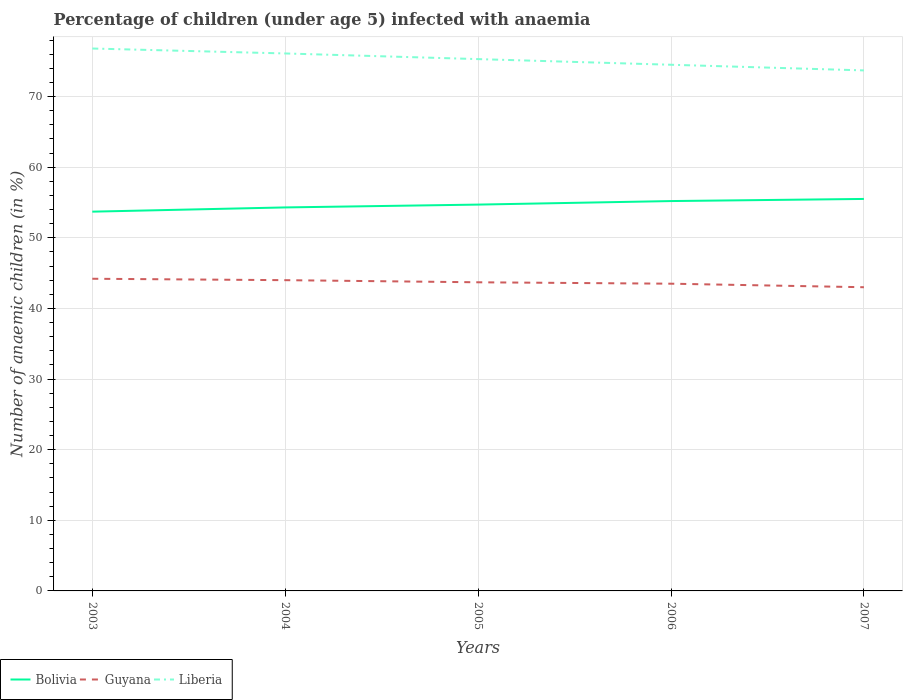Is the number of lines equal to the number of legend labels?
Provide a succinct answer. Yes. Across all years, what is the maximum percentage of children infected with anaemia in in Bolivia?
Your answer should be compact. 53.7. In which year was the percentage of children infected with anaemia in in Guyana maximum?
Offer a terse response. 2007. What is the total percentage of children infected with anaemia in in Guyana in the graph?
Your answer should be compact. 1.2. What is the difference between the highest and the second highest percentage of children infected with anaemia in in Liberia?
Give a very brief answer. 3.1. Is the percentage of children infected with anaemia in in Liberia strictly greater than the percentage of children infected with anaemia in in Guyana over the years?
Your response must be concise. No. How many years are there in the graph?
Make the answer very short. 5. Does the graph contain any zero values?
Your answer should be very brief. No. Does the graph contain grids?
Give a very brief answer. Yes. What is the title of the graph?
Provide a succinct answer. Percentage of children (under age 5) infected with anaemia. Does "France" appear as one of the legend labels in the graph?
Keep it short and to the point. No. What is the label or title of the Y-axis?
Make the answer very short. Number of anaemic children (in %). What is the Number of anaemic children (in %) in Bolivia in 2003?
Give a very brief answer. 53.7. What is the Number of anaemic children (in %) in Guyana in 2003?
Your answer should be compact. 44.2. What is the Number of anaemic children (in %) in Liberia in 2003?
Your response must be concise. 76.8. What is the Number of anaemic children (in %) of Bolivia in 2004?
Keep it short and to the point. 54.3. What is the Number of anaemic children (in %) in Liberia in 2004?
Your answer should be very brief. 76.1. What is the Number of anaemic children (in %) in Bolivia in 2005?
Provide a succinct answer. 54.7. What is the Number of anaemic children (in %) of Guyana in 2005?
Keep it short and to the point. 43.7. What is the Number of anaemic children (in %) in Liberia in 2005?
Make the answer very short. 75.3. What is the Number of anaemic children (in %) in Bolivia in 2006?
Your answer should be very brief. 55.2. What is the Number of anaemic children (in %) in Guyana in 2006?
Your answer should be compact. 43.5. What is the Number of anaemic children (in %) of Liberia in 2006?
Your answer should be compact. 74.5. What is the Number of anaemic children (in %) of Bolivia in 2007?
Provide a succinct answer. 55.5. What is the Number of anaemic children (in %) of Liberia in 2007?
Provide a succinct answer. 73.7. Across all years, what is the maximum Number of anaemic children (in %) in Bolivia?
Offer a terse response. 55.5. Across all years, what is the maximum Number of anaemic children (in %) of Guyana?
Your answer should be compact. 44.2. Across all years, what is the maximum Number of anaemic children (in %) of Liberia?
Offer a very short reply. 76.8. Across all years, what is the minimum Number of anaemic children (in %) of Bolivia?
Offer a terse response. 53.7. Across all years, what is the minimum Number of anaemic children (in %) in Guyana?
Offer a terse response. 43. Across all years, what is the minimum Number of anaemic children (in %) in Liberia?
Your answer should be compact. 73.7. What is the total Number of anaemic children (in %) of Bolivia in the graph?
Your answer should be very brief. 273.4. What is the total Number of anaemic children (in %) of Guyana in the graph?
Ensure brevity in your answer.  218.4. What is the total Number of anaemic children (in %) in Liberia in the graph?
Your response must be concise. 376.4. What is the difference between the Number of anaemic children (in %) of Guyana in 2003 and that in 2004?
Provide a short and direct response. 0.2. What is the difference between the Number of anaemic children (in %) in Bolivia in 2003 and that in 2005?
Offer a very short reply. -1. What is the difference between the Number of anaemic children (in %) of Guyana in 2003 and that in 2005?
Your answer should be very brief. 0.5. What is the difference between the Number of anaemic children (in %) of Liberia in 2003 and that in 2005?
Provide a short and direct response. 1.5. What is the difference between the Number of anaemic children (in %) of Bolivia in 2003 and that in 2006?
Make the answer very short. -1.5. What is the difference between the Number of anaemic children (in %) in Liberia in 2003 and that in 2006?
Provide a succinct answer. 2.3. What is the difference between the Number of anaemic children (in %) in Bolivia in 2003 and that in 2007?
Give a very brief answer. -1.8. What is the difference between the Number of anaemic children (in %) of Liberia in 2003 and that in 2007?
Provide a succinct answer. 3.1. What is the difference between the Number of anaemic children (in %) in Bolivia in 2004 and that in 2006?
Provide a short and direct response. -0.9. What is the difference between the Number of anaemic children (in %) of Guyana in 2004 and that in 2006?
Give a very brief answer. 0.5. What is the difference between the Number of anaemic children (in %) in Liberia in 2004 and that in 2006?
Give a very brief answer. 1.6. What is the difference between the Number of anaemic children (in %) in Liberia in 2004 and that in 2007?
Your answer should be very brief. 2.4. What is the difference between the Number of anaemic children (in %) of Liberia in 2005 and that in 2006?
Provide a short and direct response. 0.8. What is the difference between the Number of anaemic children (in %) in Bolivia in 2005 and that in 2007?
Your response must be concise. -0.8. What is the difference between the Number of anaemic children (in %) of Liberia in 2005 and that in 2007?
Ensure brevity in your answer.  1.6. What is the difference between the Number of anaemic children (in %) in Bolivia in 2003 and the Number of anaemic children (in %) in Guyana in 2004?
Provide a succinct answer. 9.7. What is the difference between the Number of anaemic children (in %) in Bolivia in 2003 and the Number of anaemic children (in %) in Liberia in 2004?
Make the answer very short. -22.4. What is the difference between the Number of anaemic children (in %) of Guyana in 2003 and the Number of anaemic children (in %) of Liberia in 2004?
Keep it short and to the point. -31.9. What is the difference between the Number of anaemic children (in %) of Bolivia in 2003 and the Number of anaemic children (in %) of Liberia in 2005?
Your answer should be compact. -21.6. What is the difference between the Number of anaemic children (in %) in Guyana in 2003 and the Number of anaemic children (in %) in Liberia in 2005?
Provide a short and direct response. -31.1. What is the difference between the Number of anaemic children (in %) of Bolivia in 2003 and the Number of anaemic children (in %) of Guyana in 2006?
Give a very brief answer. 10.2. What is the difference between the Number of anaemic children (in %) in Bolivia in 2003 and the Number of anaemic children (in %) in Liberia in 2006?
Keep it short and to the point. -20.8. What is the difference between the Number of anaemic children (in %) of Guyana in 2003 and the Number of anaemic children (in %) of Liberia in 2006?
Ensure brevity in your answer.  -30.3. What is the difference between the Number of anaemic children (in %) in Bolivia in 2003 and the Number of anaemic children (in %) in Guyana in 2007?
Provide a short and direct response. 10.7. What is the difference between the Number of anaemic children (in %) in Bolivia in 2003 and the Number of anaemic children (in %) in Liberia in 2007?
Give a very brief answer. -20. What is the difference between the Number of anaemic children (in %) of Guyana in 2003 and the Number of anaemic children (in %) of Liberia in 2007?
Ensure brevity in your answer.  -29.5. What is the difference between the Number of anaemic children (in %) of Guyana in 2004 and the Number of anaemic children (in %) of Liberia in 2005?
Ensure brevity in your answer.  -31.3. What is the difference between the Number of anaemic children (in %) of Bolivia in 2004 and the Number of anaemic children (in %) of Liberia in 2006?
Your response must be concise. -20.2. What is the difference between the Number of anaemic children (in %) of Guyana in 2004 and the Number of anaemic children (in %) of Liberia in 2006?
Give a very brief answer. -30.5. What is the difference between the Number of anaemic children (in %) of Bolivia in 2004 and the Number of anaemic children (in %) of Liberia in 2007?
Provide a succinct answer. -19.4. What is the difference between the Number of anaemic children (in %) in Guyana in 2004 and the Number of anaemic children (in %) in Liberia in 2007?
Make the answer very short. -29.7. What is the difference between the Number of anaemic children (in %) in Bolivia in 2005 and the Number of anaemic children (in %) in Guyana in 2006?
Provide a succinct answer. 11.2. What is the difference between the Number of anaemic children (in %) in Bolivia in 2005 and the Number of anaemic children (in %) in Liberia in 2006?
Provide a short and direct response. -19.8. What is the difference between the Number of anaemic children (in %) of Guyana in 2005 and the Number of anaemic children (in %) of Liberia in 2006?
Make the answer very short. -30.8. What is the difference between the Number of anaemic children (in %) of Bolivia in 2005 and the Number of anaemic children (in %) of Guyana in 2007?
Provide a short and direct response. 11.7. What is the difference between the Number of anaemic children (in %) in Bolivia in 2006 and the Number of anaemic children (in %) in Guyana in 2007?
Provide a short and direct response. 12.2. What is the difference between the Number of anaemic children (in %) in Bolivia in 2006 and the Number of anaemic children (in %) in Liberia in 2007?
Give a very brief answer. -18.5. What is the difference between the Number of anaemic children (in %) in Guyana in 2006 and the Number of anaemic children (in %) in Liberia in 2007?
Ensure brevity in your answer.  -30.2. What is the average Number of anaemic children (in %) in Bolivia per year?
Offer a terse response. 54.68. What is the average Number of anaemic children (in %) of Guyana per year?
Your answer should be very brief. 43.68. What is the average Number of anaemic children (in %) in Liberia per year?
Make the answer very short. 75.28. In the year 2003, what is the difference between the Number of anaemic children (in %) of Bolivia and Number of anaemic children (in %) of Liberia?
Your answer should be compact. -23.1. In the year 2003, what is the difference between the Number of anaemic children (in %) of Guyana and Number of anaemic children (in %) of Liberia?
Your answer should be very brief. -32.6. In the year 2004, what is the difference between the Number of anaemic children (in %) of Bolivia and Number of anaemic children (in %) of Guyana?
Your answer should be compact. 10.3. In the year 2004, what is the difference between the Number of anaemic children (in %) of Bolivia and Number of anaemic children (in %) of Liberia?
Your answer should be very brief. -21.8. In the year 2004, what is the difference between the Number of anaemic children (in %) of Guyana and Number of anaemic children (in %) of Liberia?
Give a very brief answer. -32.1. In the year 2005, what is the difference between the Number of anaemic children (in %) of Bolivia and Number of anaemic children (in %) of Guyana?
Make the answer very short. 11. In the year 2005, what is the difference between the Number of anaemic children (in %) of Bolivia and Number of anaemic children (in %) of Liberia?
Give a very brief answer. -20.6. In the year 2005, what is the difference between the Number of anaemic children (in %) in Guyana and Number of anaemic children (in %) in Liberia?
Make the answer very short. -31.6. In the year 2006, what is the difference between the Number of anaemic children (in %) of Bolivia and Number of anaemic children (in %) of Guyana?
Your answer should be very brief. 11.7. In the year 2006, what is the difference between the Number of anaemic children (in %) of Bolivia and Number of anaemic children (in %) of Liberia?
Offer a very short reply. -19.3. In the year 2006, what is the difference between the Number of anaemic children (in %) of Guyana and Number of anaemic children (in %) of Liberia?
Provide a succinct answer. -31. In the year 2007, what is the difference between the Number of anaemic children (in %) in Bolivia and Number of anaemic children (in %) in Liberia?
Your answer should be compact. -18.2. In the year 2007, what is the difference between the Number of anaemic children (in %) in Guyana and Number of anaemic children (in %) in Liberia?
Your answer should be very brief. -30.7. What is the ratio of the Number of anaemic children (in %) in Liberia in 2003 to that in 2004?
Provide a succinct answer. 1.01. What is the ratio of the Number of anaemic children (in %) of Bolivia in 2003 to that in 2005?
Your answer should be compact. 0.98. What is the ratio of the Number of anaemic children (in %) in Guyana in 2003 to that in 2005?
Your response must be concise. 1.01. What is the ratio of the Number of anaemic children (in %) in Liberia in 2003 to that in 2005?
Make the answer very short. 1.02. What is the ratio of the Number of anaemic children (in %) of Bolivia in 2003 to that in 2006?
Offer a very short reply. 0.97. What is the ratio of the Number of anaemic children (in %) of Guyana in 2003 to that in 2006?
Your response must be concise. 1.02. What is the ratio of the Number of anaemic children (in %) in Liberia in 2003 to that in 2006?
Your answer should be compact. 1.03. What is the ratio of the Number of anaemic children (in %) of Bolivia in 2003 to that in 2007?
Provide a succinct answer. 0.97. What is the ratio of the Number of anaemic children (in %) in Guyana in 2003 to that in 2007?
Give a very brief answer. 1.03. What is the ratio of the Number of anaemic children (in %) of Liberia in 2003 to that in 2007?
Your answer should be compact. 1.04. What is the ratio of the Number of anaemic children (in %) in Guyana in 2004 to that in 2005?
Offer a terse response. 1.01. What is the ratio of the Number of anaemic children (in %) in Liberia in 2004 to that in 2005?
Make the answer very short. 1.01. What is the ratio of the Number of anaemic children (in %) of Bolivia in 2004 to that in 2006?
Make the answer very short. 0.98. What is the ratio of the Number of anaemic children (in %) of Guyana in 2004 to that in 2006?
Offer a very short reply. 1.01. What is the ratio of the Number of anaemic children (in %) in Liberia in 2004 to that in 2006?
Give a very brief answer. 1.02. What is the ratio of the Number of anaemic children (in %) of Bolivia in 2004 to that in 2007?
Ensure brevity in your answer.  0.98. What is the ratio of the Number of anaemic children (in %) of Guyana in 2004 to that in 2007?
Your answer should be compact. 1.02. What is the ratio of the Number of anaemic children (in %) of Liberia in 2004 to that in 2007?
Your response must be concise. 1.03. What is the ratio of the Number of anaemic children (in %) in Bolivia in 2005 to that in 2006?
Keep it short and to the point. 0.99. What is the ratio of the Number of anaemic children (in %) in Guyana in 2005 to that in 2006?
Your answer should be compact. 1. What is the ratio of the Number of anaemic children (in %) of Liberia in 2005 to that in 2006?
Keep it short and to the point. 1.01. What is the ratio of the Number of anaemic children (in %) of Bolivia in 2005 to that in 2007?
Provide a succinct answer. 0.99. What is the ratio of the Number of anaemic children (in %) of Guyana in 2005 to that in 2007?
Provide a succinct answer. 1.02. What is the ratio of the Number of anaemic children (in %) in Liberia in 2005 to that in 2007?
Give a very brief answer. 1.02. What is the ratio of the Number of anaemic children (in %) of Guyana in 2006 to that in 2007?
Make the answer very short. 1.01. What is the ratio of the Number of anaemic children (in %) of Liberia in 2006 to that in 2007?
Keep it short and to the point. 1.01. What is the difference between the highest and the second highest Number of anaemic children (in %) in Liberia?
Make the answer very short. 0.7. What is the difference between the highest and the lowest Number of anaemic children (in %) in Liberia?
Your answer should be very brief. 3.1. 